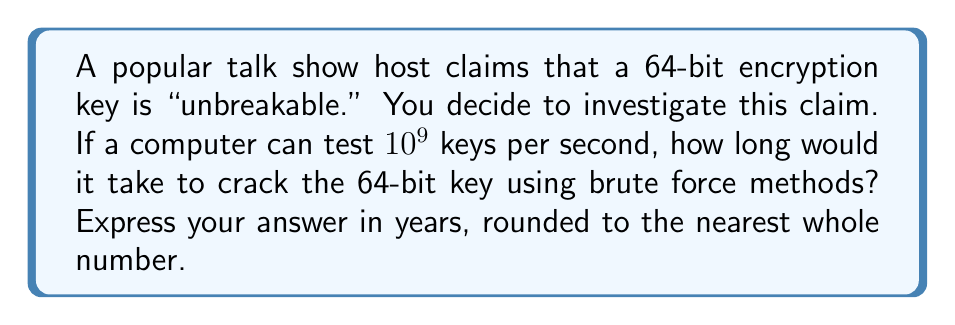Teach me how to tackle this problem. Let's approach this step-by-step:

1) First, we need to calculate the total number of possible keys for a 64-bit encryption:
   $$2^{64} = 18,446,744,073,709,551,616$$

2) Now, we know that the computer can test $10^9$ keys per second. Let's calculate how many seconds it would take to test all keys:
   $$\frac{2^{64}}{10^9} = \frac{18,446,744,073,709,551,616}{1,000,000,000} = 18,446,744,073.709551616 \text{ seconds}$$

3) To convert this to years, we need to divide by the number of seconds in a year:
   Seconds in a year = 365 days × 24 hours × 60 minutes × 60 seconds = 31,536,000

4) Years to crack the key:
   $$\frac{18,446,744,073.709551616}{31,536,000} = 584.942417355072 \text{ years}$$

5) Rounding to the nearest whole number:
   585 years

This result shows that while the 64-bit key isn't technically "unbreakable," it would take an extremely long time to crack using brute force methods with the given computing power, challenging your initial skepticism of the talk show host's claim.
Answer: 585 years 